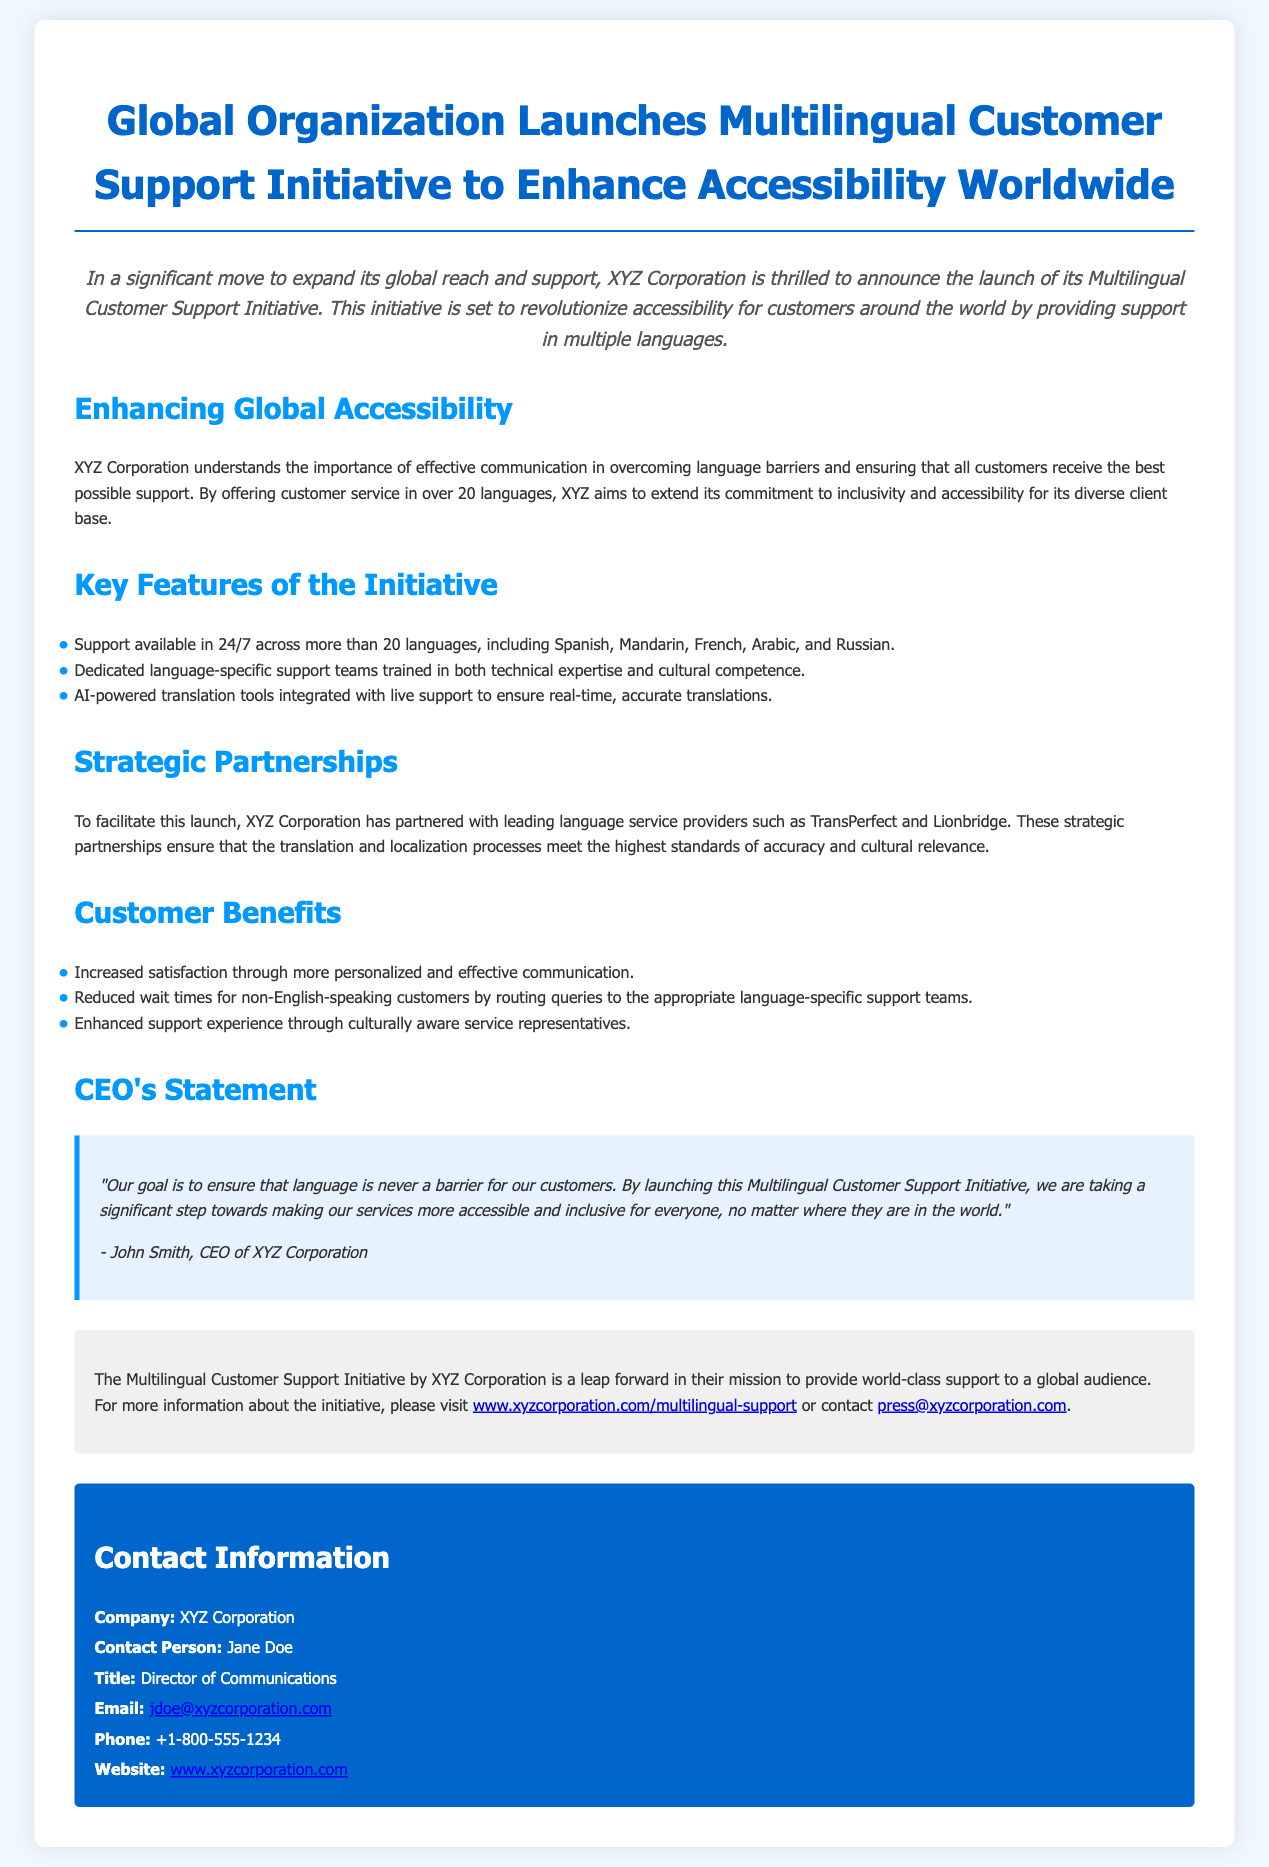What is the title of the press release? The title presents the main announcement regarding the initiative focused on multilingual support to enhance accessibility.
Answer: Global Organization Launches Multilingual Customer Support Initiative to Enhance Accessibility Worldwide How many languages will the customer support be available in? The document specifies the number of languages available for customer support, highlighting inclusivity.
Answer: more than 20 languages Who is the CEO of XYZ Corporation? The CEO's name is mentioned in the statement that emphasizes the importance of language accessibility for customers.
Answer: John Smith What are the names of the strategic partners mentioned? This information highlights the collaboration efforts of XYZ Corporation to ensure quality service in the multilingual initiative.
Answer: TransPerfect and Lionbridge What benefit is highlighted regarding non-English-speaking customers? The document discusses improvements in the customer experience, especially for non-English-speaking individuals.
Answer: Reduced wait times Why is this initiative significant for XYZ Corporation? The press release outlines the broader impact on customer support and inclusivity, indicating the strategic importance of the initiative.
Answer: Accessibility and inclusivity What tool is integrated with live support for translations? This mentions the technological aspect of the initiative, focusing on enhancing communication efficiency.
Answer: AI-powered translation tools What type of support teams will be available? The document describes the composition of the support teams that will address customer inquiries in various languages.
Answer: Dedicated language-specific support teams 